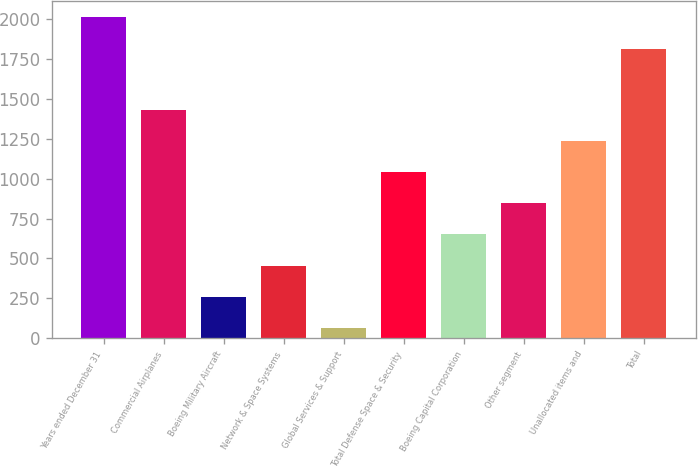Convert chart to OTSL. <chart><loc_0><loc_0><loc_500><loc_500><bar_chart><fcel>Years ended December 31<fcel>Commercial Airplanes<fcel>Boeing Military Aircraft<fcel>Network & Space Systems<fcel>Global Services & Support<fcel>Total Defense Space & Security<fcel>Boeing Capital Corporation<fcel>Other segment<fcel>Unallocated items and<fcel>Total<nl><fcel>2012<fcel>1428.5<fcel>261.5<fcel>456<fcel>67<fcel>1039.5<fcel>650.5<fcel>845<fcel>1234<fcel>1811<nl></chart> 